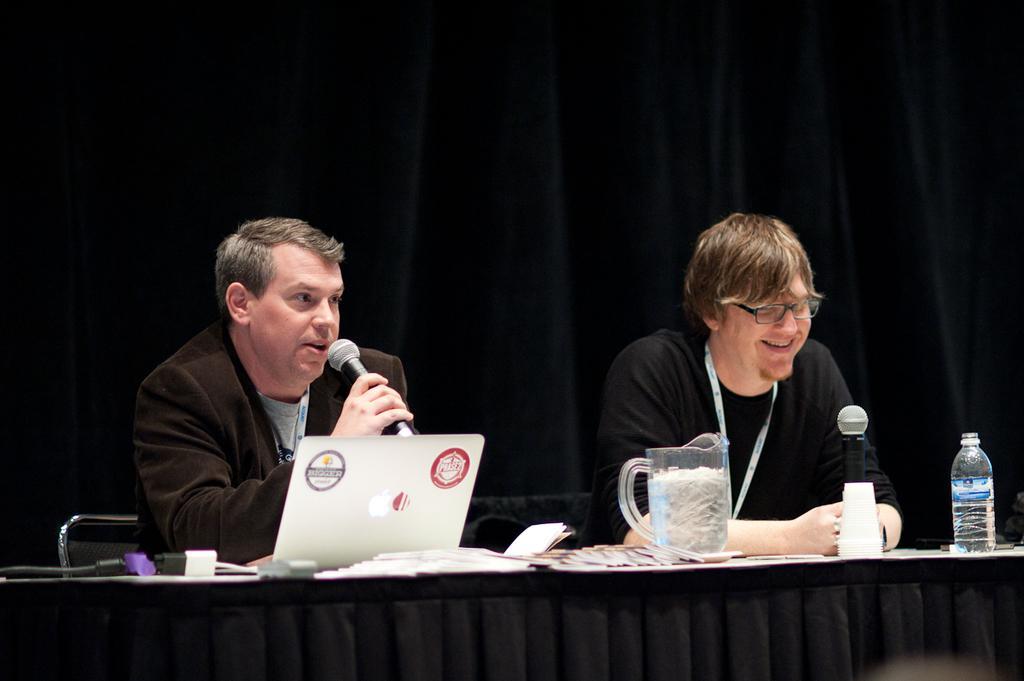Please provide a concise description of this image. There are two people sitting on chair. In front of them there is a table. On the table there are laptop, paper, jug,bottle. Both of them are holding mic. The person in the right wearing black dress is smiling. he is wearing glasses. The person in the left is holding mic is talking something. In the background there is a black curtain. 